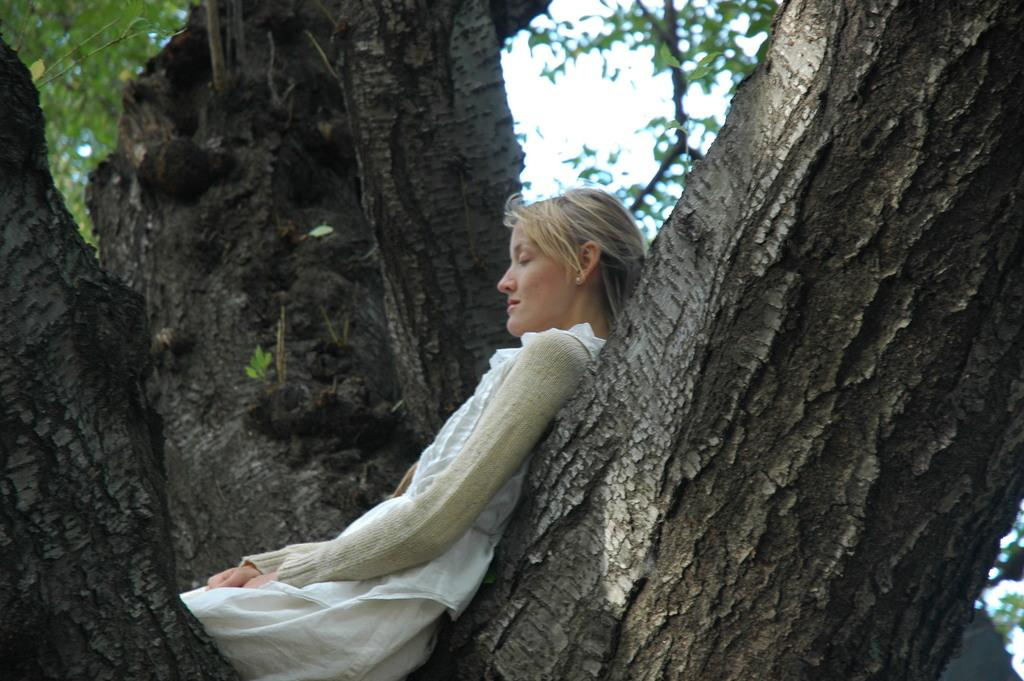Who is the main subject in the image? There is a woman in the image. What is the woman wearing? The woman is wearing a dress. Where is the woman sitting in the image? The woman is sitting on a tree branch. What can be seen in the background of the image? There are trees and the sky visible in the background of the image. How many children are playing in the hole in the image? There are no children or holes present in the image. 